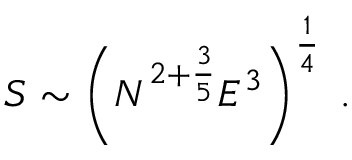Convert formula to latex. <formula><loc_0><loc_0><loc_500><loc_500>S \sim \left ( N ^ { 2 + \frac { 3 } { 5 } } E ^ { 3 } \right ) ^ { \frac { 1 } { 4 } } \, .</formula> 